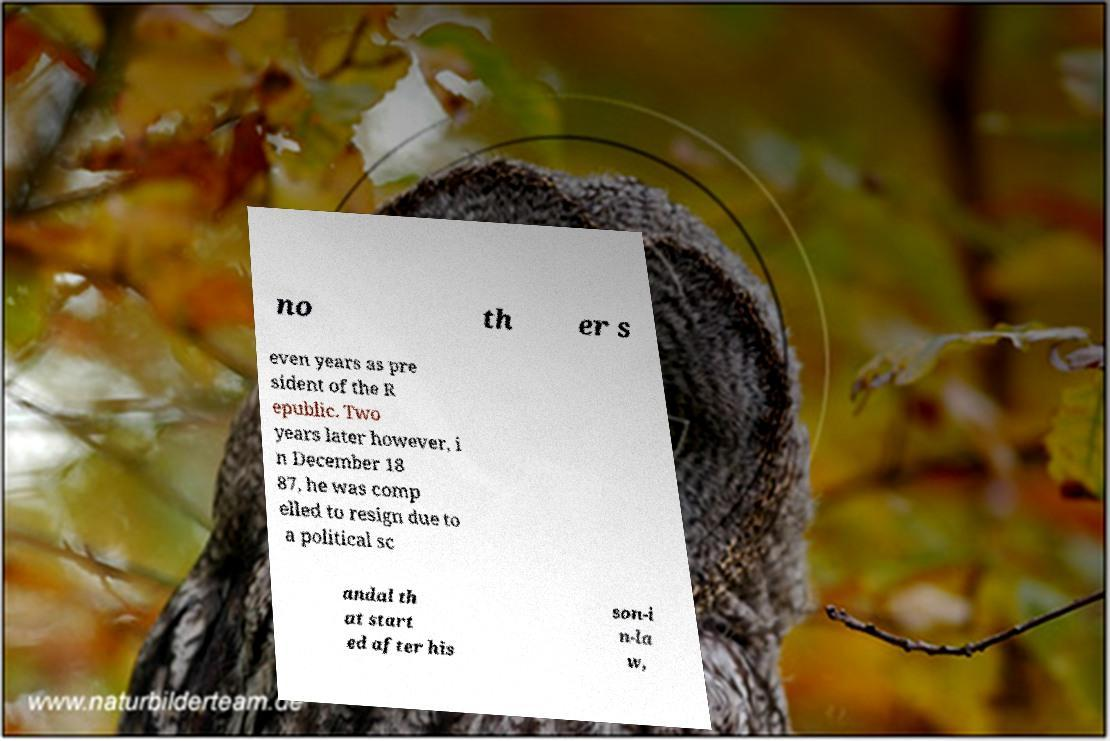I need the written content from this picture converted into text. Can you do that? no th er s even years as pre sident of the R epublic. Two years later however, i n December 18 87, he was comp elled to resign due to a political sc andal th at start ed after his son-i n-la w, 